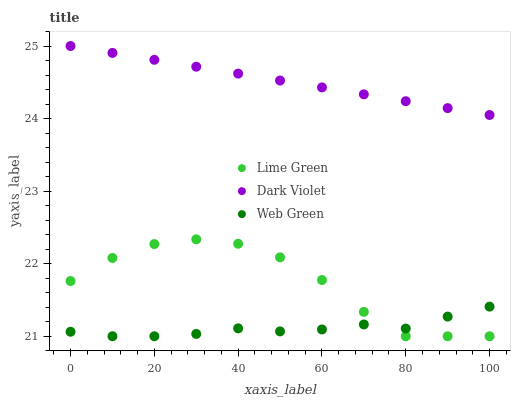Does Web Green have the minimum area under the curve?
Answer yes or no. Yes. Does Dark Violet have the maximum area under the curve?
Answer yes or no. Yes. Does Dark Violet have the minimum area under the curve?
Answer yes or no. No. Does Web Green have the maximum area under the curve?
Answer yes or no. No. Is Dark Violet the smoothest?
Answer yes or no. Yes. Is Lime Green the roughest?
Answer yes or no. Yes. Is Web Green the smoothest?
Answer yes or no. No. Is Web Green the roughest?
Answer yes or no. No. Does Lime Green have the lowest value?
Answer yes or no. Yes. Does Dark Violet have the lowest value?
Answer yes or no. No. Does Dark Violet have the highest value?
Answer yes or no. Yes. Does Web Green have the highest value?
Answer yes or no. No. Is Web Green less than Dark Violet?
Answer yes or no. Yes. Is Dark Violet greater than Lime Green?
Answer yes or no. Yes. Does Lime Green intersect Web Green?
Answer yes or no. Yes. Is Lime Green less than Web Green?
Answer yes or no. No. Is Lime Green greater than Web Green?
Answer yes or no. No. Does Web Green intersect Dark Violet?
Answer yes or no. No. 